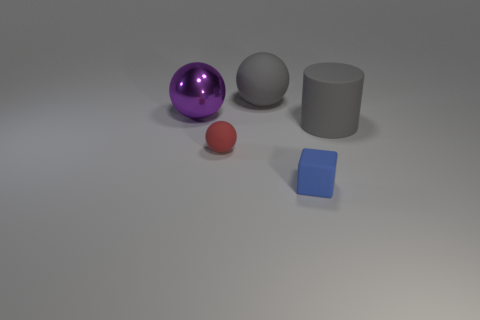What size is the blue matte cube?
Make the answer very short. Small. What number of shiny spheres are the same size as the block?
Offer a terse response. 0. Is the small sphere the same color as the block?
Make the answer very short. No. Are the large thing that is on the right side of the tiny blue thing and the sphere left of the tiny red matte sphere made of the same material?
Your response must be concise. No. Is the number of blue matte cylinders greater than the number of rubber blocks?
Offer a very short reply. No. Is there any other thing of the same color as the small matte cube?
Keep it short and to the point. No. Does the cube have the same material as the gray sphere?
Make the answer very short. Yes. Is the number of large gray cylinders less than the number of brown rubber balls?
Your response must be concise. No. Is the shape of the blue matte object the same as the tiny red object?
Provide a succinct answer. No. What color is the tiny rubber cube?
Your response must be concise. Blue. 